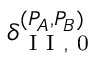Convert formula to latex. <formula><loc_0><loc_0><loc_500><loc_500>\delta _ { I I , 0 } ^ { ( P _ { A } , P _ { B } ) }</formula> 